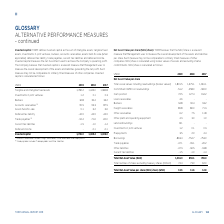According to Torm's financial document, What does accounts receivables in the table include? Freight receivables, Other receivables and Prepayments. The document states: "¹ ⁾ Accounts receivables includes Freight receivables, Other receivables and Prepayments. ² ⁾ Trade payables includes Trade payables and Other liabili..." Also, What does trade payables in the table include? Trade payables and Other liabilities. The document states: "bles and Prepayments. ² ⁾ Trade payables includes Trade payables and Other liabilities...." Also, For which years was Invested capital calculated in? The document contains multiple relevant values: 2019, 2018, 2017. From the document: "USDm 2019 2018 2017 USDm 2019 2018 2017 USDm 2019 2018 2017..." Additionally, In which year was the amount of assets held-for-sale the largest? According to the financial document, 2019. The relevant text states: "USDm 2019 2018 2017..." Also, can you calculate: What was the change in invested capital in 2019 from 2018? Based on the calculation: 1,786.0-1,469.4, the result is 316.6 (in millions). This is based on the information: "Invested capital 1,786.0 1,469.4 1,406.0 Invested capital 1,786.0 1,469.4 1,406.0..." The key data points involved are: 1,469.4, 1,786.0. Also, can you calculate: What was the percentage change in invested capital in 2019 from 2018? To answer this question, I need to perform calculations using the financial data. The calculation is: (1,786.0-1,469.4)/1,469.4, which equals 21.55 (percentage). This is based on the information: "Invested capital 1,786.0 1,469.4 1,406.0 Invested capital 1,786.0 1,469.4 1,406.0..." The key data points involved are: 1,469.4, 1,786.0. 